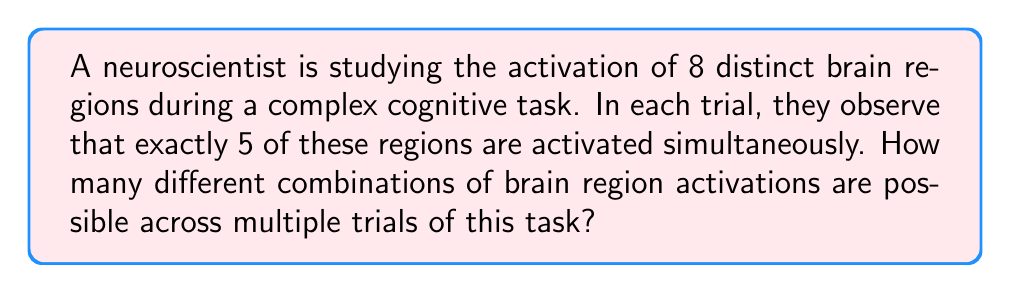Could you help me with this problem? To solve this problem, we need to use the concept of combinations. We are selecting 5 regions out of 8, where the order doesn't matter (as we're only interested in which regions are activated, not the sequence of activation).

The formula for combinations is:

$$C(n,r) = \frac{n!}{r!(n-r)!}$$

Where:
$n$ is the total number of items to choose from (in this case, 8 brain regions)
$r$ is the number of items being chosen (in this case, 5 activated regions)

Let's substitute these values:

$$C(8,5) = \frac{8!}{5!(8-5)!} = \frac{8!}{5!(3)!}$$

Now, let's calculate this step-by-step:

1) $8! = 8 \times 7 \times 6 \times 5 \times 4 \times 3 \times 2 \times 1 = 40,320$
2) $5! = 5 \times 4 \times 3 \times 2 \times 1 = 120$
3) $3! = 3 \times 2 \times 1 = 6$

Substituting these values:

$$C(8,5) = \frac{40,320}{120 \times 6} = \frac{40,320}{720} = 56$$

Therefore, there are 56 different possible combinations of brain region activations.
Answer: 56 combinations 